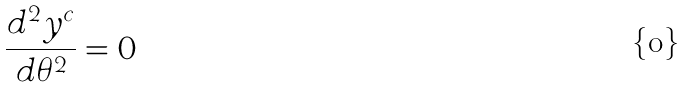Convert formula to latex. <formula><loc_0><loc_0><loc_500><loc_500>\frac { d ^ { 2 } y ^ { c } } { d \theta ^ { 2 } } = 0</formula> 